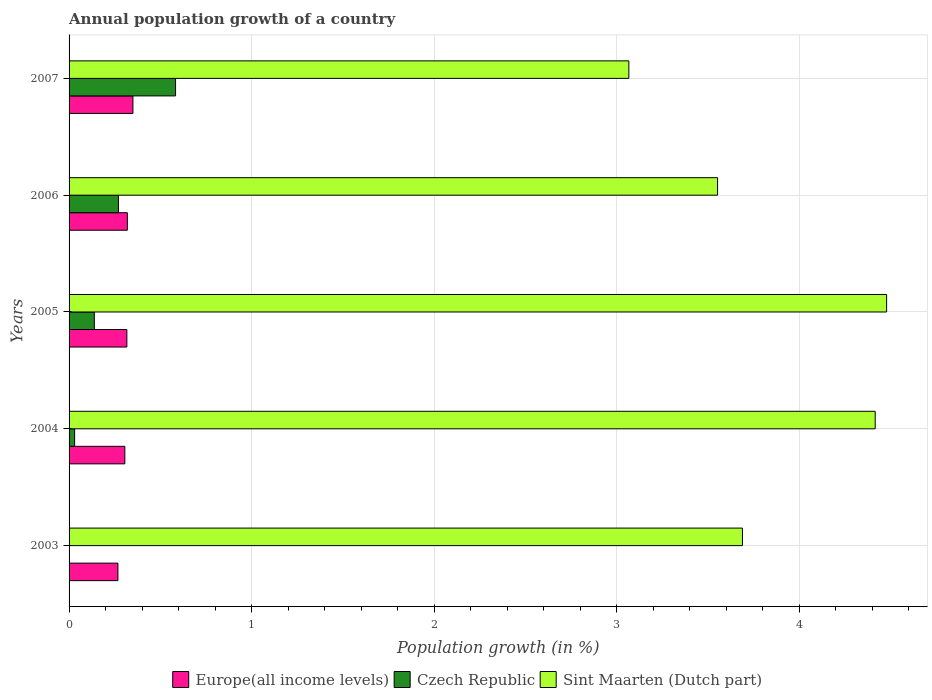How many groups of bars are there?
Provide a short and direct response. 5. Are the number of bars per tick equal to the number of legend labels?
Provide a succinct answer. No. What is the label of the 2nd group of bars from the top?
Offer a terse response. 2006. In how many cases, is the number of bars for a given year not equal to the number of legend labels?
Give a very brief answer. 1. What is the annual population growth in Czech Republic in 2007?
Make the answer very short. 0.58. Across all years, what is the maximum annual population growth in Czech Republic?
Offer a very short reply. 0.58. Across all years, what is the minimum annual population growth in Sint Maarten (Dutch part)?
Make the answer very short. 3.07. What is the total annual population growth in Czech Republic in the graph?
Keep it short and to the point. 1.02. What is the difference between the annual population growth in Europe(all income levels) in 2003 and that in 2006?
Give a very brief answer. -0.05. What is the difference between the annual population growth in Czech Republic in 2005 and the annual population growth in Europe(all income levels) in 2007?
Your response must be concise. -0.21. What is the average annual population growth in Europe(all income levels) per year?
Give a very brief answer. 0.31. In the year 2004, what is the difference between the annual population growth in Europe(all income levels) and annual population growth in Czech Republic?
Offer a very short reply. 0.28. What is the ratio of the annual population growth in Europe(all income levels) in 2004 to that in 2005?
Provide a short and direct response. 0.96. Is the difference between the annual population growth in Europe(all income levels) in 2004 and 2007 greater than the difference between the annual population growth in Czech Republic in 2004 and 2007?
Offer a very short reply. Yes. What is the difference between the highest and the second highest annual population growth in Sint Maarten (Dutch part)?
Make the answer very short. 0.06. What is the difference between the highest and the lowest annual population growth in Europe(all income levels)?
Provide a short and direct response. 0.08. How many years are there in the graph?
Ensure brevity in your answer.  5. What is the difference between two consecutive major ticks on the X-axis?
Your response must be concise. 1. Are the values on the major ticks of X-axis written in scientific E-notation?
Your answer should be compact. No. Does the graph contain grids?
Keep it short and to the point. Yes. Where does the legend appear in the graph?
Your answer should be compact. Bottom center. How many legend labels are there?
Give a very brief answer. 3. What is the title of the graph?
Ensure brevity in your answer.  Annual population growth of a country. Does "East Asia (developing only)" appear as one of the legend labels in the graph?
Keep it short and to the point. No. What is the label or title of the X-axis?
Your answer should be compact. Population growth (in %). What is the Population growth (in %) in Europe(all income levels) in 2003?
Offer a terse response. 0.27. What is the Population growth (in %) of Czech Republic in 2003?
Make the answer very short. 0. What is the Population growth (in %) in Sint Maarten (Dutch part) in 2003?
Your answer should be compact. 3.69. What is the Population growth (in %) of Europe(all income levels) in 2004?
Provide a short and direct response. 0.31. What is the Population growth (in %) of Czech Republic in 2004?
Make the answer very short. 0.03. What is the Population growth (in %) of Sint Maarten (Dutch part) in 2004?
Provide a short and direct response. 4.42. What is the Population growth (in %) in Europe(all income levels) in 2005?
Keep it short and to the point. 0.32. What is the Population growth (in %) in Czech Republic in 2005?
Make the answer very short. 0.14. What is the Population growth (in %) of Sint Maarten (Dutch part) in 2005?
Offer a very short reply. 4.48. What is the Population growth (in %) of Europe(all income levels) in 2006?
Ensure brevity in your answer.  0.32. What is the Population growth (in %) in Czech Republic in 2006?
Your response must be concise. 0.27. What is the Population growth (in %) in Sint Maarten (Dutch part) in 2006?
Offer a terse response. 3.55. What is the Population growth (in %) in Europe(all income levels) in 2007?
Your answer should be very brief. 0.35. What is the Population growth (in %) in Czech Republic in 2007?
Offer a very short reply. 0.58. What is the Population growth (in %) of Sint Maarten (Dutch part) in 2007?
Your response must be concise. 3.07. Across all years, what is the maximum Population growth (in %) of Europe(all income levels)?
Give a very brief answer. 0.35. Across all years, what is the maximum Population growth (in %) of Czech Republic?
Provide a succinct answer. 0.58. Across all years, what is the maximum Population growth (in %) in Sint Maarten (Dutch part)?
Provide a short and direct response. 4.48. Across all years, what is the minimum Population growth (in %) of Europe(all income levels)?
Provide a succinct answer. 0.27. Across all years, what is the minimum Population growth (in %) in Czech Republic?
Offer a terse response. 0. Across all years, what is the minimum Population growth (in %) in Sint Maarten (Dutch part)?
Give a very brief answer. 3.07. What is the total Population growth (in %) in Europe(all income levels) in the graph?
Offer a very short reply. 1.56. What is the total Population growth (in %) of Czech Republic in the graph?
Give a very brief answer. 1.02. What is the total Population growth (in %) of Sint Maarten (Dutch part) in the graph?
Offer a very short reply. 19.21. What is the difference between the Population growth (in %) of Europe(all income levels) in 2003 and that in 2004?
Give a very brief answer. -0.04. What is the difference between the Population growth (in %) of Sint Maarten (Dutch part) in 2003 and that in 2004?
Provide a short and direct response. -0.73. What is the difference between the Population growth (in %) of Europe(all income levels) in 2003 and that in 2005?
Your answer should be compact. -0.05. What is the difference between the Population growth (in %) of Sint Maarten (Dutch part) in 2003 and that in 2005?
Your response must be concise. -0.79. What is the difference between the Population growth (in %) of Europe(all income levels) in 2003 and that in 2006?
Provide a succinct answer. -0.05. What is the difference between the Population growth (in %) of Sint Maarten (Dutch part) in 2003 and that in 2006?
Your answer should be very brief. 0.14. What is the difference between the Population growth (in %) of Europe(all income levels) in 2003 and that in 2007?
Offer a terse response. -0.08. What is the difference between the Population growth (in %) of Sint Maarten (Dutch part) in 2003 and that in 2007?
Offer a very short reply. 0.62. What is the difference between the Population growth (in %) of Europe(all income levels) in 2004 and that in 2005?
Offer a very short reply. -0.01. What is the difference between the Population growth (in %) of Czech Republic in 2004 and that in 2005?
Keep it short and to the point. -0.11. What is the difference between the Population growth (in %) of Sint Maarten (Dutch part) in 2004 and that in 2005?
Give a very brief answer. -0.06. What is the difference between the Population growth (in %) of Europe(all income levels) in 2004 and that in 2006?
Provide a succinct answer. -0.01. What is the difference between the Population growth (in %) of Czech Republic in 2004 and that in 2006?
Keep it short and to the point. -0.24. What is the difference between the Population growth (in %) of Sint Maarten (Dutch part) in 2004 and that in 2006?
Your response must be concise. 0.86. What is the difference between the Population growth (in %) in Europe(all income levels) in 2004 and that in 2007?
Ensure brevity in your answer.  -0.04. What is the difference between the Population growth (in %) of Czech Republic in 2004 and that in 2007?
Offer a very short reply. -0.55. What is the difference between the Population growth (in %) in Sint Maarten (Dutch part) in 2004 and that in 2007?
Offer a terse response. 1.35. What is the difference between the Population growth (in %) in Europe(all income levels) in 2005 and that in 2006?
Your answer should be very brief. -0. What is the difference between the Population growth (in %) of Czech Republic in 2005 and that in 2006?
Your answer should be very brief. -0.13. What is the difference between the Population growth (in %) in Sint Maarten (Dutch part) in 2005 and that in 2006?
Offer a terse response. 0.93. What is the difference between the Population growth (in %) in Europe(all income levels) in 2005 and that in 2007?
Keep it short and to the point. -0.03. What is the difference between the Population growth (in %) in Czech Republic in 2005 and that in 2007?
Ensure brevity in your answer.  -0.45. What is the difference between the Population growth (in %) of Sint Maarten (Dutch part) in 2005 and that in 2007?
Make the answer very short. 1.41. What is the difference between the Population growth (in %) in Europe(all income levels) in 2006 and that in 2007?
Give a very brief answer. -0.03. What is the difference between the Population growth (in %) in Czech Republic in 2006 and that in 2007?
Make the answer very short. -0.31. What is the difference between the Population growth (in %) in Sint Maarten (Dutch part) in 2006 and that in 2007?
Give a very brief answer. 0.49. What is the difference between the Population growth (in %) in Europe(all income levels) in 2003 and the Population growth (in %) in Czech Republic in 2004?
Ensure brevity in your answer.  0.24. What is the difference between the Population growth (in %) of Europe(all income levels) in 2003 and the Population growth (in %) of Sint Maarten (Dutch part) in 2004?
Provide a succinct answer. -4.15. What is the difference between the Population growth (in %) of Europe(all income levels) in 2003 and the Population growth (in %) of Czech Republic in 2005?
Provide a short and direct response. 0.13. What is the difference between the Population growth (in %) in Europe(all income levels) in 2003 and the Population growth (in %) in Sint Maarten (Dutch part) in 2005?
Your answer should be compact. -4.21. What is the difference between the Population growth (in %) of Europe(all income levels) in 2003 and the Population growth (in %) of Czech Republic in 2006?
Ensure brevity in your answer.  -0. What is the difference between the Population growth (in %) of Europe(all income levels) in 2003 and the Population growth (in %) of Sint Maarten (Dutch part) in 2006?
Your response must be concise. -3.29. What is the difference between the Population growth (in %) of Europe(all income levels) in 2003 and the Population growth (in %) of Czech Republic in 2007?
Keep it short and to the point. -0.32. What is the difference between the Population growth (in %) in Europe(all income levels) in 2003 and the Population growth (in %) in Sint Maarten (Dutch part) in 2007?
Provide a short and direct response. -2.8. What is the difference between the Population growth (in %) of Europe(all income levels) in 2004 and the Population growth (in %) of Czech Republic in 2005?
Give a very brief answer. 0.17. What is the difference between the Population growth (in %) of Europe(all income levels) in 2004 and the Population growth (in %) of Sint Maarten (Dutch part) in 2005?
Provide a short and direct response. -4.17. What is the difference between the Population growth (in %) in Czech Republic in 2004 and the Population growth (in %) in Sint Maarten (Dutch part) in 2005?
Make the answer very short. -4.45. What is the difference between the Population growth (in %) of Europe(all income levels) in 2004 and the Population growth (in %) of Czech Republic in 2006?
Provide a short and direct response. 0.03. What is the difference between the Population growth (in %) of Europe(all income levels) in 2004 and the Population growth (in %) of Sint Maarten (Dutch part) in 2006?
Your answer should be compact. -3.25. What is the difference between the Population growth (in %) of Czech Republic in 2004 and the Population growth (in %) of Sint Maarten (Dutch part) in 2006?
Keep it short and to the point. -3.52. What is the difference between the Population growth (in %) in Europe(all income levels) in 2004 and the Population growth (in %) in Czech Republic in 2007?
Offer a very short reply. -0.28. What is the difference between the Population growth (in %) in Europe(all income levels) in 2004 and the Population growth (in %) in Sint Maarten (Dutch part) in 2007?
Provide a short and direct response. -2.76. What is the difference between the Population growth (in %) of Czech Republic in 2004 and the Population growth (in %) of Sint Maarten (Dutch part) in 2007?
Offer a very short reply. -3.04. What is the difference between the Population growth (in %) of Europe(all income levels) in 2005 and the Population growth (in %) of Czech Republic in 2006?
Give a very brief answer. 0.05. What is the difference between the Population growth (in %) of Europe(all income levels) in 2005 and the Population growth (in %) of Sint Maarten (Dutch part) in 2006?
Offer a very short reply. -3.24. What is the difference between the Population growth (in %) in Czech Republic in 2005 and the Population growth (in %) in Sint Maarten (Dutch part) in 2006?
Give a very brief answer. -3.42. What is the difference between the Population growth (in %) in Europe(all income levels) in 2005 and the Population growth (in %) in Czech Republic in 2007?
Give a very brief answer. -0.27. What is the difference between the Population growth (in %) in Europe(all income levels) in 2005 and the Population growth (in %) in Sint Maarten (Dutch part) in 2007?
Offer a terse response. -2.75. What is the difference between the Population growth (in %) of Czech Republic in 2005 and the Population growth (in %) of Sint Maarten (Dutch part) in 2007?
Ensure brevity in your answer.  -2.93. What is the difference between the Population growth (in %) of Europe(all income levels) in 2006 and the Population growth (in %) of Czech Republic in 2007?
Provide a succinct answer. -0.26. What is the difference between the Population growth (in %) of Europe(all income levels) in 2006 and the Population growth (in %) of Sint Maarten (Dutch part) in 2007?
Your response must be concise. -2.75. What is the difference between the Population growth (in %) in Czech Republic in 2006 and the Population growth (in %) in Sint Maarten (Dutch part) in 2007?
Your answer should be very brief. -2.8. What is the average Population growth (in %) of Europe(all income levels) per year?
Your answer should be very brief. 0.31. What is the average Population growth (in %) in Czech Republic per year?
Provide a succinct answer. 0.2. What is the average Population growth (in %) of Sint Maarten (Dutch part) per year?
Offer a very short reply. 3.84. In the year 2003, what is the difference between the Population growth (in %) of Europe(all income levels) and Population growth (in %) of Sint Maarten (Dutch part)?
Provide a short and direct response. -3.42. In the year 2004, what is the difference between the Population growth (in %) of Europe(all income levels) and Population growth (in %) of Czech Republic?
Offer a very short reply. 0.28. In the year 2004, what is the difference between the Population growth (in %) of Europe(all income levels) and Population growth (in %) of Sint Maarten (Dutch part)?
Offer a very short reply. -4.11. In the year 2004, what is the difference between the Population growth (in %) of Czech Republic and Population growth (in %) of Sint Maarten (Dutch part)?
Keep it short and to the point. -4.39. In the year 2005, what is the difference between the Population growth (in %) of Europe(all income levels) and Population growth (in %) of Czech Republic?
Provide a succinct answer. 0.18. In the year 2005, what is the difference between the Population growth (in %) of Europe(all income levels) and Population growth (in %) of Sint Maarten (Dutch part)?
Give a very brief answer. -4.16. In the year 2005, what is the difference between the Population growth (in %) in Czech Republic and Population growth (in %) in Sint Maarten (Dutch part)?
Ensure brevity in your answer.  -4.34. In the year 2006, what is the difference between the Population growth (in %) in Europe(all income levels) and Population growth (in %) in Czech Republic?
Provide a succinct answer. 0.05. In the year 2006, what is the difference between the Population growth (in %) in Europe(all income levels) and Population growth (in %) in Sint Maarten (Dutch part)?
Ensure brevity in your answer.  -3.23. In the year 2006, what is the difference between the Population growth (in %) in Czech Republic and Population growth (in %) in Sint Maarten (Dutch part)?
Ensure brevity in your answer.  -3.28. In the year 2007, what is the difference between the Population growth (in %) in Europe(all income levels) and Population growth (in %) in Czech Republic?
Your answer should be compact. -0.23. In the year 2007, what is the difference between the Population growth (in %) in Europe(all income levels) and Population growth (in %) in Sint Maarten (Dutch part)?
Your response must be concise. -2.72. In the year 2007, what is the difference between the Population growth (in %) of Czech Republic and Population growth (in %) of Sint Maarten (Dutch part)?
Your response must be concise. -2.48. What is the ratio of the Population growth (in %) of Europe(all income levels) in 2003 to that in 2004?
Offer a very short reply. 0.88. What is the ratio of the Population growth (in %) of Sint Maarten (Dutch part) in 2003 to that in 2004?
Give a very brief answer. 0.84. What is the ratio of the Population growth (in %) in Europe(all income levels) in 2003 to that in 2005?
Make the answer very short. 0.85. What is the ratio of the Population growth (in %) of Sint Maarten (Dutch part) in 2003 to that in 2005?
Your answer should be compact. 0.82. What is the ratio of the Population growth (in %) in Europe(all income levels) in 2003 to that in 2006?
Offer a terse response. 0.84. What is the ratio of the Population growth (in %) in Sint Maarten (Dutch part) in 2003 to that in 2006?
Ensure brevity in your answer.  1.04. What is the ratio of the Population growth (in %) in Europe(all income levels) in 2003 to that in 2007?
Your answer should be very brief. 0.77. What is the ratio of the Population growth (in %) of Sint Maarten (Dutch part) in 2003 to that in 2007?
Your answer should be compact. 1.2. What is the ratio of the Population growth (in %) in Europe(all income levels) in 2004 to that in 2005?
Provide a short and direct response. 0.96. What is the ratio of the Population growth (in %) in Czech Republic in 2004 to that in 2005?
Your answer should be very brief. 0.22. What is the ratio of the Population growth (in %) in Europe(all income levels) in 2004 to that in 2006?
Keep it short and to the point. 0.96. What is the ratio of the Population growth (in %) of Czech Republic in 2004 to that in 2006?
Your answer should be compact. 0.11. What is the ratio of the Population growth (in %) in Sint Maarten (Dutch part) in 2004 to that in 2006?
Offer a terse response. 1.24. What is the ratio of the Population growth (in %) of Europe(all income levels) in 2004 to that in 2007?
Offer a terse response. 0.87. What is the ratio of the Population growth (in %) of Czech Republic in 2004 to that in 2007?
Provide a short and direct response. 0.05. What is the ratio of the Population growth (in %) of Sint Maarten (Dutch part) in 2004 to that in 2007?
Provide a short and direct response. 1.44. What is the ratio of the Population growth (in %) of Czech Republic in 2005 to that in 2006?
Your response must be concise. 0.51. What is the ratio of the Population growth (in %) in Sint Maarten (Dutch part) in 2005 to that in 2006?
Your answer should be very brief. 1.26. What is the ratio of the Population growth (in %) of Europe(all income levels) in 2005 to that in 2007?
Your response must be concise. 0.91. What is the ratio of the Population growth (in %) of Czech Republic in 2005 to that in 2007?
Make the answer very short. 0.24. What is the ratio of the Population growth (in %) of Sint Maarten (Dutch part) in 2005 to that in 2007?
Ensure brevity in your answer.  1.46. What is the ratio of the Population growth (in %) in Europe(all income levels) in 2006 to that in 2007?
Make the answer very short. 0.91. What is the ratio of the Population growth (in %) in Czech Republic in 2006 to that in 2007?
Give a very brief answer. 0.46. What is the ratio of the Population growth (in %) in Sint Maarten (Dutch part) in 2006 to that in 2007?
Provide a short and direct response. 1.16. What is the difference between the highest and the second highest Population growth (in %) in Europe(all income levels)?
Your answer should be very brief. 0.03. What is the difference between the highest and the second highest Population growth (in %) in Czech Republic?
Offer a very short reply. 0.31. What is the difference between the highest and the second highest Population growth (in %) of Sint Maarten (Dutch part)?
Your answer should be compact. 0.06. What is the difference between the highest and the lowest Population growth (in %) in Europe(all income levels)?
Provide a short and direct response. 0.08. What is the difference between the highest and the lowest Population growth (in %) in Czech Republic?
Provide a succinct answer. 0.58. What is the difference between the highest and the lowest Population growth (in %) in Sint Maarten (Dutch part)?
Make the answer very short. 1.41. 